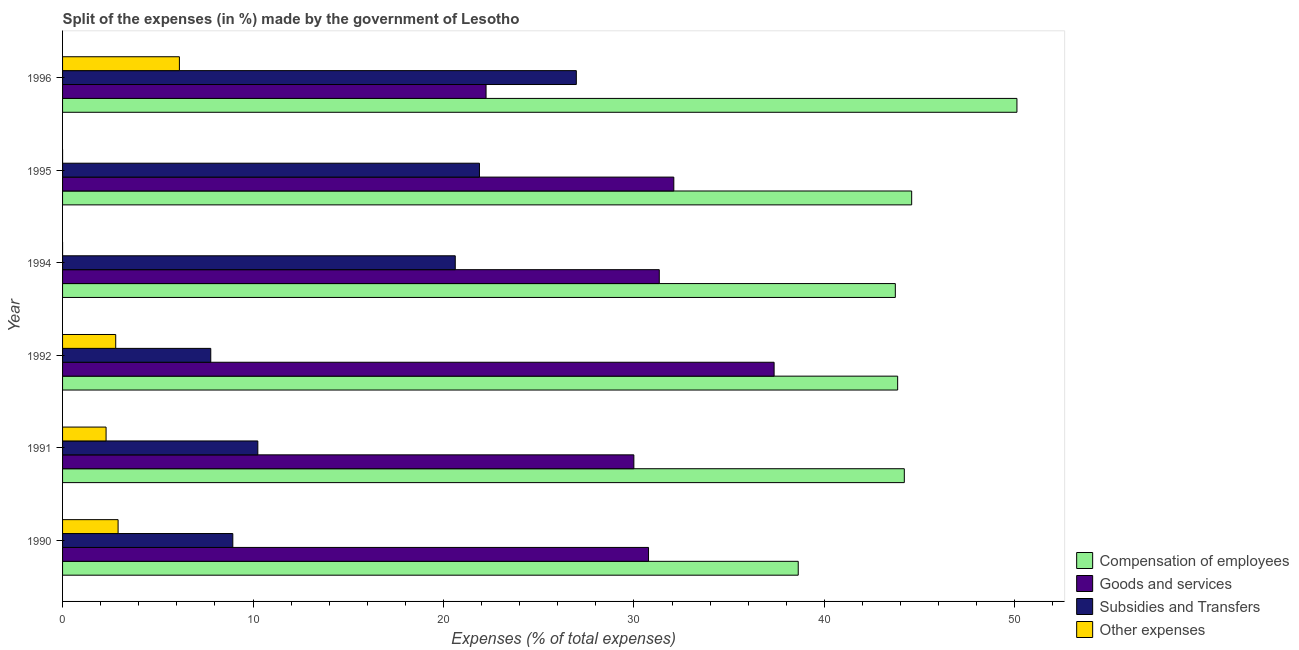How many groups of bars are there?
Ensure brevity in your answer.  6. Are the number of bars per tick equal to the number of legend labels?
Keep it short and to the point. Yes. Are the number of bars on each tick of the Y-axis equal?
Give a very brief answer. Yes. In how many cases, is the number of bars for a given year not equal to the number of legend labels?
Your answer should be compact. 0. What is the percentage of amount spent on goods and services in 1992?
Keep it short and to the point. 37.36. Across all years, what is the maximum percentage of amount spent on goods and services?
Make the answer very short. 37.36. Across all years, what is the minimum percentage of amount spent on subsidies?
Ensure brevity in your answer.  7.78. In which year was the percentage of amount spent on subsidies minimum?
Offer a very short reply. 1992. What is the total percentage of amount spent on other expenses in the graph?
Your response must be concise. 14.13. What is the difference between the percentage of amount spent on compensation of employees in 1992 and that in 1995?
Ensure brevity in your answer.  -0.74. What is the difference between the percentage of amount spent on subsidies in 1995 and the percentage of amount spent on other expenses in 1990?
Offer a terse response. 18.97. What is the average percentage of amount spent on compensation of employees per year?
Ensure brevity in your answer.  44.18. In the year 1992, what is the difference between the percentage of amount spent on goods and services and percentage of amount spent on other expenses?
Keep it short and to the point. 34.57. What is the ratio of the percentage of amount spent on compensation of employees in 1994 to that in 1995?
Make the answer very short. 0.98. Is the percentage of amount spent on subsidies in 1992 less than that in 1996?
Your response must be concise. Yes. Is the difference between the percentage of amount spent on goods and services in 1990 and 1994 greater than the difference between the percentage of amount spent on compensation of employees in 1990 and 1994?
Your response must be concise. Yes. What is the difference between the highest and the second highest percentage of amount spent on goods and services?
Provide a succinct answer. 5.27. What is the difference between the highest and the lowest percentage of amount spent on goods and services?
Your answer should be very brief. 15.12. In how many years, is the percentage of amount spent on compensation of employees greater than the average percentage of amount spent on compensation of employees taken over all years?
Provide a succinct answer. 3. Is the sum of the percentage of amount spent on goods and services in 1990 and 1991 greater than the maximum percentage of amount spent on other expenses across all years?
Your answer should be compact. Yes. Is it the case that in every year, the sum of the percentage of amount spent on subsidies and percentage of amount spent on compensation of employees is greater than the sum of percentage of amount spent on goods and services and percentage of amount spent on other expenses?
Your answer should be very brief. No. What does the 3rd bar from the top in 1995 represents?
Your response must be concise. Goods and services. What does the 3rd bar from the bottom in 1994 represents?
Ensure brevity in your answer.  Subsidies and Transfers. Is it the case that in every year, the sum of the percentage of amount spent on compensation of employees and percentage of amount spent on goods and services is greater than the percentage of amount spent on subsidies?
Provide a succinct answer. Yes. Are the values on the major ticks of X-axis written in scientific E-notation?
Provide a short and direct response. No. Does the graph contain any zero values?
Ensure brevity in your answer.  No. How many legend labels are there?
Make the answer very short. 4. What is the title of the graph?
Your answer should be compact. Split of the expenses (in %) made by the government of Lesotho. What is the label or title of the X-axis?
Offer a very short reply. Expenses (% of total expenses). What is the Expenses (% of total expenses) of Compensation of employees in 1990?
Your answer should be very brief. 38.63. What is the Expenses (% of total expenses) of Goods and services in 1990?
Offer a very short reply. 30.77. What is the Expenses (% of total expenses) of Subsidies and Transfers in 1990?
Make the answer very short. 8.94. What is the Expenses (% of total expenses) of Other expenses in 1990?
Your response must be concise. 2.92. What is the Expenses (% of total expenses) of Compensation of employees in 1991?
Offer a very short reply. 44.2. What is the Expenses (% of total expenses) of Goods and services in 1991?
Provide a succinct answer. 30. What is the Expenses (% of total expenses) of Subsidies and Transfers in 1991?
Your response must be concise. 10.25. What is the Expenses (% of total expenses) of Other expenses in 1991?
Provide a succinct answer. 2.28. What is the Expenses (% of total expenses) in Compensation of employees in 1992?
Give a very brief answer. 43.85. What is the Expenses (% of total expenses) of Goods and services in 1992?
Your response must be concise. 37.36. What is the Expenses (% of total expenses) in Subsidies and Transfers in 1992?
Provide a short and direct response. 7.78. What is the Expenses (% of total expenses) in Other expenses in 1992?
Your answer should be very brief. 2.79. What is the Expenses (% of total expenses) in Compensation of employees in 1994?
Provide a short and direct response. 43.73. What is the Expenses (% of total expenses) in Goods and services in 1994?
Your answer should be very brief. 31.33. What is the Expenses (% of total expenses) of Subsidies and Transfers in 1994?
Your answer should be very brief. 20.62. What is the Expenses (% of total expenses) in Other expenses in 1994?
Make the answer very short. 2.999997087200831e-5. What is the Expenses (% of total expenses) in Compensation of employees in 1995?
Make the answer very short. 44.58. What is the Expenses (% of total expenses) in Goods and services in 1995?
Your answer should be compact. 32.1. What is the Expenses (% of total expenses) in Subsidies and Transfers in 1995?
Your answer should be very brief. 21.89. What is the Expenses (% of total expenses) in Other expenses in 1995?
Make the answer very short. 0. What is the Expenses (% of total expenses) in Compensation of employees in 1996?
Give a very brief answer. 50.11. What is the Expenses (% of total expenses) in Goods and services in 1996?
Give a very brief answer. 22.24. What is the Expenses (% of total expenses) of Subsidies and Transfers in 1996?
Ensure brevity in your answer.  26.98. What is the Expenses (% of total expenses) of Other expenses in 1996?
Offer a very short reply. 6.14. Across all years, what is the maximum Expenses (% of total expenses) of Compensation of employees?
Your answer should be compact. 50.11. Across all years, what is the maximum Expenses (% of total expenses) of Goods and services?
Offer a very short reply. 37.36. Across all years, what is the maximum Expenses (% of total expenses) of Subsidies and Transfers?
Your answer should be very brief. 26.98. Across all years, what is the maximum Expenses (% of total expenses) in Other expenses?
Offer a very short reply. 6.14. Across all years, what is the minimum Expenses (% of total expenses) of Compensation of employees?
Provide a succinct answer. 38.63. Across all years, what is the minimum Expenses (% of total expenses) in Goods and services?
Your answer should be compact. 22.24. Across all years, what is the minimum Expenses (% of total expenses) of Subsidies and Transfers?
Your answer should be compact. 7.78. Across all years, what is the minimum Expenses (% of total expenses) of Other expenses?
Give a very brief answer. 2.999997087200831e-5. What is the total Expenses (% of total expenses) of Compensation of employees in the graph?
Keep it short and to the point. 265.1. What is the total Expenses (% of total expenses) of Goods and services in the graph?
Make the answer very short. 183.79. What is the total Expenses (% of total expenses) of Subsidies and Transfers in the graph?
Keep it short and to the point. 96.46. What is the total Expenses (% of total expenses) in Other expenses in the graph?
Make the answer very short. 14.13. What is the difference between the Expenses (% of total expenses) of Compensation of employees in 1990 and that in 1991?
Offer a terse response. -5.57. What is the difference between the Expenses (% of total expenses) in Goods and services in 1990 and that in 1991?
Your answer should be very brief. 0.77. What is the difference between the Expenses (% of total expenses) in Subsidies and Transfers in 1990 and that in 1991?
Give a very brief answer. -1.31. What is the difference between the Expenses (% of total expenses) of Other expenses in 1990 and that in 1991?
Give a very brief answer. 0.63. What is the difference between the Expenses (% of total expenses) in Compensation of employees in 1990 and that in 1992?
Your answer should be very brief. -5.22. What is the difference between the Expenses (% of total expenses) of Goods and services in 1990 and that in 1992?
Keep it short and to the point. -6.59. What is the difference between the Expenses (% of total expenses) of Subsidies and Transfers in 1990 and that in 1992?
Give a very brief answer. 1.16. What is the difference between the Expenses (% of total expenses) of Other expenses in 1990 and that in 1992?
Your answer should be very brief. 0.13. What is the difference between the Expenses (% of total expenses) of Compensation of employees in 1990 and that in 1994?
Make the answer very short. -5.1. What is the difference between the Expenses (% of total expenses) of Goods and services in 1990 and that in 1994?
Ensure brevity in your answer.  -0.56. What is the difference between the Expenses (% of total expenses) of Subsidies and Transfers in 1990 and that in 1994?
Make the answer very short. -11.68. What is the difference between the Expenses (% of total expenses) in Other expenses in 1990 and that in 1994?
Make the answer very short. 2.92. What is the difference between the Expenses (% of total expenses) in Compensation of employees in 1990 and that in 1995?
Your response must be concise. -5.96. What is the difference between the Expenses (% of total expenses) in Goods and services in 1990 and that in 1995?
Make the answer very short. -1.33. What is the difference between the Expenses (% of total expenses) in Subsidies and Transfers in 1990 and that in 1995?
Offer a very short reply. -12.95. What is the difference between the Expenses (% of total expenses) of Other expenses in 1990 and that in 1995?
Provide a short and direct response. 2.92. What is the difference between the Expenses (% of total expenses) in Compensation of employees in 1990 and that in 1996?
Make the answer very short. -11.48. What is the difference between the Expenses (% of total expenses) in Goods and services in 1990 and that in 1996?
Your answer should be very brief. 8.53. What is the difference between the Expenses (% of total expenses) of Subsidies and Transfers in 1990 and that in 1996?
Offer a terse response. -18.04. What is the difference between the Expenses (% of total expenses) of Other expenses in 1990 and that in 1996?
Your response must be concise. -3.22. What is the difference between the Expenses (% of total expenses) in Compensation of employees in 1991 and that in 1992?
Give a very brief answer. 0.35. What is the difference between the Expenses (% of total expenses) of Goods and services in 1991 and that in 1992?
Make the answer very short. -7.36. What is the difference between the Expenses (% of total expenses) in Subsidies and Transfers in 1991 and that in 1992?
Ensure brevity in your answer.  2.47. What is the difference between the Expenses (% of total expenses) of Other expenses in 1991 and that in 1992?
Offer a terse response. -0.51. What is the difference between the Expenses (% of total expenses) of Compensation of employees in 1991 and that in 1994?
Your answer should be compact. 0.47. What is the difference between the Expenses (% of total expenses) of Goods and services in 1991 and that in 1994?
Provide a short and direct response. -1.33. What is the difference between the Expenses (% of total expenses) in Subsidies and Transfers in 1991 and that in 1994?
Provide a succinct answer. -10.37. What is the difference between the Expenses (% of total expenses) of Other expenses in 1991 and that in 1994?
Offer a very short reply. 2.28. What is the difference between the Expenses (% of total expenses) of Compensation of employees in 1991 and that in 1995?
Offer a terse response. -0.39. What is the difference between the Expenses (% of total expenses) in Goods and services in 1991 and that in 1995?
Make the answer very short. -2.1. What is the difference between the Expenses (% of total expenses) in Subsidies and Transfers in 1991 and that in 1995?
Offer a very short reply. -11.64. What is the difference between the Expenses (% of total expenses) in Other expenses in 1991 and that in 1995?
Provide a short and direct response. 2.28. What is the difference between the Expenses (% of total expenses) in Compensation of employees in 1991 and that in 1996?
Your answer should be very brief. -5.91. What is the difference between the Expenses (% of total expenses) of Goods and services in 1991 and that in 1996?
Provide a succinct answer. 7.76. What is the difference between the Expenses (% of total expenses) of Subsidies and Transfers in 1991 and that in 1996?
Make the answer very short. -16.72. What is the difference between the Expenses (% of total expenses) in Other expenses in 1991 and that in 1996?
Provide a succinct answer. -3.85. What is the difference between the Expenses (% of total expenses) of Compensation of employees in 1992 and that in 1994?
Provide a short and direct response. 0.12. What is the difference between the Expenses (% of total expenses) in Goods and services in 1992 and that in 1994?
Make the answer very short. 6.03. What is the difference between the Expenses (% of total expenses) in Subsidies and Transfers in 1992 and that in 1994?
Offer a very short reply. -12.84. What is the difference between the Expenses (% of total expenses) in Other expenses in 1992 and that in 1994?
Make the answer very short. 2.79. What is the difference between the Expenses (% of total expenses) of Compensation of employees in 1992 and that in 1995?
Make the answer very short. -0.74. What is the difference between the Expenses (% of total expenses) in Goods and services in 1992 and that in 1995?
Keep it short and to the point. 5.27. What is the difference between the Expenses (% of total expenses) in Subsidies and Transfers in 1992 and that in 1995?
Your answer should be compact. -14.11. What is the difference between the Expenses (% of total expenses) in Other expenses in 1992 and that in 1995?
Offer a terse response. 2.79. What is the difference between the Expenses (% of total expenses) of Compensation of employees in 1992 and that in 1996?
Offer a terse response. -6.26. What is the difference between the Expenses (% of total expenses) in Goods and services in 1992 and that in 1996?
Keep it short and to the point. 15.12. What is the difference between the Expenses (% of total expenses) in Subsidies and Transfers in 1992 and that in 1996?
Offer a very short reply. -19.2. What is the difference between the Expenses (% of total expenses) of Other expenses in 1992 and that in 1996?
Your answer should be very brief. -3.34. What is the difference between the Expenses (% of total expenses) in Compensation of employees in 1994 and that in 1995?
Keep it short and to the point. -0.86. What is the difference between the Expenses (% of total expenses) of Goods and services in 1994 and that in 1995?
Offer a very short reply. -0.76. What is the difference between the Expenses (% of total expenses) in Subsidies and Transfers in 1994 and that in 1995?
Offer a very short reply. -1.27. What is the difference between the Expenses (% of total expenses) of Other expenses in 1994 and that in 1995?
Provide a succinct answer. -0. What is the difference between the Expenses (% of total expenses) in Compensation of employees in 1994 and that in 1996?
Your answer should be compact. -6.39. What is the difference between the Expenses (% of total expenses) of Goods and services in 1994 and that in 1996?
Provide a succinct answer. 9.1. What is the difference between the Expenses (% of total expenses) in Subsidies and Transfers in 1994 and that in 1996?
Provide a short and direct response. -6.36. What is the difference between the Expenses (% of total expenses) in Other expenses in 1994 and that in 1996?
Your response must be concise. -6.14. What is the difference between the Expenses (% of total expenses) of Compensation of employees in 1995 and that in 1996?
Offer a terse response. -5.53. What is the difference between the Expenses (% of total expenses) in Goods and services in 1995 and that in 1996?
Offer a terse response. 9.86. What is the difference between the Expenses (% of total expenses) in Subsidies and Transfers in 1995 and that in 1996?
Keep it short and to the point. -5.09. What is the difference between the Expenses (% of total expenses) of Other expenses in 1995 and that in 1996?
Your answer should be very brief. -6.14. What is the difference between the Expenses (% of total expenses) in Compensation of employees in 1990 and the Expenses (% of total expenses) in Goods and services in 1991?
Your answer should be very brief. 8.63. What is the difference between the Expenses (% of total expenses) of Compensation of employees in 1990 and the Expenses (% of total expenses) of Subsidies and Transfers in 1991?
Offer a very short reply. 28.38. What is the difference between the Expenses (% of total expenses) in Compensation of employees in 1990 and the Expenses (% of total expenses) in Other expenses in 1991?
Your answer should be very brief. 36.34. What is the difference between the Expenses (% of total expenses) in Goods and services in 1990 and the Expenses (% of total expenses) in Subsidies and Transfers in 1991?
Ensure brevity in your answer.  20.52. What is the difference between the Expenses (% of total expenses) in Goods and services in 1990 and the Expenses (% of total expenses) in Other expenses in 1991?
Ensure brevity in your answer.  28.48. What is the difference between the Expenses (% of total expenses) of Subsidies and Transfers in 1990 and the Expenses (% of total expenses) of Other expenses in 1991?
Keep it short and to the point. 6.65. What is the difference between the Expenses (% of total expenses) of Compensation of employees in 1990 and the Expenses (% of total expenses) of Goods and services in 1992?
Your response must be concise. 1.27. What is the difference between the Expenses (% of total expenses) of Compensation of employees in 1990 and the Expenses (% of total expenses) of Subsidies and Transfers in 1992?
Make the answer very short. 30.85. What is the difference between the Expenses (% of total expenses) of Compensation of employees in 1990 and the Expenses (% of total expenses) of Other expenses in 1992?
Provide a short and direct response. 35.84. What is the difference between the Expenses (% of total expenses) of Goods and services in 1990 and the Expenses (% of total expenses) of Subsidies and Transfers in 1992?
Provide a succinct answer. 22.99. What is the difference between the Expenses (% of total expenses) in Goods and services in 1990 and the Expenses (% of total expenses) in Other expenses in 1992?
Your response must be concise. 27.98. What is the difference between the Expenses (% of total expenses) in Subsidies and Transfers in 1990 and the Expenses (% of total expenses) in Other expenses in 1992?
Your answer should be very brief. 6.15. What is the difference between the Expenses (% of total expenses) of Compensation of employees in 1990 and the Expenses (% of total expenses) of Goods and services in 1994?
Make the answer very short. 7.3. What is the difference between the Expenses (% of total expenses) of Compensation of employees in 1990 and the Expenses (% of total expenses) of Subsidies and Transfers in 1994?
Ensure brevity in your answer.  18.01. What is the difference between the Expenses (% of total expenses) in Compensation of employees in 1990 and the Expenses (% of total expenses) in Other expenses in 1994?
Give a very brief answer. 38.63. What is the difference between the Expenses (% of total expenses) in Goods and services in 1990 and the Expenses (% of total expenses) in Subsidies and Transfers in 1994?
Give a very brief answer. 10.15. What is the difference between the Expenses (% of total expenses) in Goods and services in 1990 and the Expenses (% of total expenses) in Other expenses in 1994?
Ensure brevity in your answer.  30.77. What is the difference between the Expenses (% of total expenses) in Subsidies and Transfers in 1990 and the Expenses (% of total expenses) in Other expenses in 1994?
Your response must be concise. 8.94. What is the difference between the Expenses (% of total expenses) in Compensation of employees in 1990 and the Expenses (% of total expenses) in Goods and services in 1995?
Your answer should be very brief. 6.53. What is the difference between the Expenses (% of total expenses) of Compensation of employees in 1990 and the Expenses (% of total expenses) of Subsidies and Transfers in 1995?
Offer a terse response. 16.74. What is the difference between the Expenses (% of total expenses) of Compensation of employees in 1990 and the Expenses (% of total expenses) of Other expenses in 1995?
Make the answer very short. 38.63. What is the difference between the Expenses (% of total expenses) in Goods and services in 1990 and the Expenses (% of total expenses) in Subsidies and Transfers in 1995?
Keep it short and to the point. 8.88. What is the difference between the Expenses (% of total expenses) of Goods and services in 1990 and the Expenses (% of total expenses) of Other expenses in 1995?
Offer a very short reply. 30.77. What is the difference between the Expenses (% of total expenses) of Subsidies and Transfers in 1990 and the Expenses (% of total expenses) of Other expenses in 1995?
Ensure brevity in your answer.  8.94. What is the difference between the Expenses (% of total expenses) of Compensation of employees in 1990 and the Expenses (% of total expenses) of Goods and services in 1996?
Make the answer very short. 16.39. What is the difference between the Expenses (% of total expenses) in Compensation of employees in 1990 and the Expenses (% of total expenses) in Subsidies and Transfers in 1996?
Make the answer very short. 11.65. What is the difference between the Expenses (% of total expenses) of Compensation of employees in 1990 and the Expenses (% of total expenses) of Other expenses in 1996?
Ensure brevity in your answer.  32.49. What is the difference between the Expenses (% of total expenses) of Goods and services in 1990 and the Expenses (% of total expenses) of Subsidies and Transfers in 1996?
Provide a short and direct response. 3.79. What is the difference between the Expenses (% of total expenses) of Goods and services in 1990 and the Expenses (% of total expenses) of Other expenses in 1996?
Your answer should be compact. 24.63. What is the difference between the Expenses (% of total expenses) in Subsidies and Transfers in 1990 and the Expenses (% of total expenses) in Other expenses in 1996?
Your response must be concise. 2.8. What is the difference between the Expenses (% of total expenses) of Compensation of employees in 1991 and the Expenses (% of total expenses) of Goods and services in 1992?
Provide a succinct answer. 6.84. What is the difference between the Expenses (% of total expenses) of Compensation of employees in 1991 and the Expenses (% of total expenses) of Subsidies and Transfers in 1992?
Offer a very short reply. 36.42. What is the difference between the Expenses (% of total expenses) in Compensation of employees in 1991 and the Expenses (% of total expenses) in Other expenses in 1992?
Offer a terse response. 41.41. What is the difference between the Expenses (% of total expenses) of Goods and services in 1991 and the Expenses (% of total expenses) of Subsidies and Transfers in 1992?
Offer a very short reply. 22.22. What is the difference between the Expenses (% of total expenses) of Goods and services in 1991 and the Expenses (% of total expenses) of Other expenses in 1992?
Ensure brevity in your answer.  27.21. What is the difference between the Expenses (% of total expenses) in Subsidies and Transfers in 1991 and the Expenses (% of total expenses) in Other expenses in 1992?
Keep it short and to the point. 7.46. What is the difference between the Expenses (% of total expenses) of Compensation of employees in 1991 and the Expenses (% of total expenses) of Goods and services in 1994?
Give a very brief answer. 12.87. What is the difference between the Expenses (% of total expenses) in Compensation of employees in 1991 and the Expenses (% of total expenses) in Subsidies and Transfers in 1994?
Keep it short and to the point. 23.58. What is the difference between the Expenses (% of total expenses) in Compensation of employees in 1991 and the Expenses (% of total expenses) in Other expenses in 1994?
Your answer should be compact. 44.2. What is the difference between the Expenses (% of total expenses) in Goods and services in 1991 and the Expenses (% of total expenses) in Subsidies and Transfers in 1994?
Your response must be concise. 9.38. What is the difference between the Expenses (% of total expenses) in Goods and services in 1991 and the Expenses (% of total expenses) in Other expenses in 1994?
Provide a short and direct response. 30. What is the difference between the Expenses (% of total expenses) in Subsidies and Transfers in 1991 and the Expenses (% of total expenses) in Other expenses in 1994?
Make the answer very short. 10.25. What is the difference between the Expenses (% of total expenses) in Compensation of employees in 1991 and the Expenses (% of total expenses) in Goods and services in 1995?
Your response must be concise. 12.1. What is the difference between the Expenses (% of total expenses) in Compensation of employees in 1991 and the Expenses (% of total expenses) in Subsidies and Transfers in 1995?
Provide a short and direct response. 22.31. What is the difference between the Expenses (% of total expenses) of Compensation of employees in 1991 and the Expenses (% of total expenses) of Other expenses in 1995?
Give a very brief answer. 44.2. What is the difference between the Expenses (% of total expenses) in Goods and services in 1991 and the Expenses (% of total expenses) in Subsidies and Transfers in 1995?
Provide a succinct answer. 8.11. What is the difference between the Expenses (% of total expenses) of Goods and services in 1991 and the Expenses (% of total expenses) of Other expenses in 1995?
Make the answer very short. 30. What is the difference between the Expenses (% of total expenses) in Subsidies and Transfers in 1991 and the Expenses (% of total expenses) in Other expenses in 1995?
Your response must be concise. 10.25. What is the difference between the Expenses (% of total expenses) of Compensation of employees in 1991 and the Expenses (% of total expenses) of Goods and services in 1996?
Your answer should be very brief. 21.96. What is the difference between the Expenses (% of total expenses) in Compensation of employees in 1991 and the Expenses (% of total expenses) in Subsidies and Transfers in 1996?
Ensure brevity in your answer.  17.22. What is the difference between the Expenses (% of total expenses) in Compensation of employees in 1991 and the Expenses (% of total expenses) in Other expenses in 1996?
Provide a succinct answer. 38.06. What is the difference between the Expenses (% of total expenses) of Goods and services in 1991 and the Expenses (% of total expenses) of Subsidies and Transfers in 1996?
Provide a succinct answer. 3.02. What is the difference between the Expenses (% of total expenses) in Goods and services in 1991 and the Expenses (% of total expenses) in Other expenses in 1996?
Keep it short and to the point. 23.86. What is the difference between the Expenses (% of total expenses) of Subsidies and Transfers in 1991 and the Expenses (% of total expenses) of Other expenses in 1996?
Offer a very short reply. 4.12. What is the difference between the Expenses (% of total expenses) in Compensation of employees in 1992 and the Expenses (% of total expenses) in Goods and services in 1994?
Offer a terse response. 12.52. What is the difference between the Expenses (% of total expenses) of Compensation of employees in 1992 and the Expenses (% of total expenses) of Subsidies and Transfers in 1994?
Make the answer very short. 23.23. What is the difference between the Expenses (% of total expenses) of Compensation of employees in 1992 and the Expenses (% of total expenses) of Other expenses in 1994?
Provide a succinct answer. 43.85. What is the difference between the Expenses (% of total expenses) of Goods and services in 1992 and the Expenses (% of total expenses) of Subsidies and Transfers in 1994?
Make the answer very short. 16.74. What is the difference between the Expenses (% of total expenses) of Goods and services in 1992 and the Expenses (% of total expenses) of Other expenses in 1994?
Ensure brevity in your answer.  37.36. What is the difference between the Expenses (% of total expenses) in Subsidies and Transfers in 1992 and the Expenses (% of total expenses) in Other expenses in 1994?
Your answer should be compact. 7.78. What is the difference between the Expenses (% of total expenses) in Compensation of employees in 1992 and the Expenses (% of total expenses) in Goods and services in 1995?
Your response must be concise. 11.75. What is the difference between the Expenses (% of total expenses) in Compensation of employees in 1992 and the Expenses (% of total expenses) in Subsidies and Transfers in 1995?
Ensure brevity in your answer.  21.96. What is the difference between the Expenses (% of total expenses) in Compensation of employees in 1992 and the Expenses (% of total expenses) in Other expenses in 1995?
Give a very brief answer. 43.85. What is the difference between the Expenses (% of total expenses) in Goods and services in 1992 and the Expenses (% of total expenses) in Subsidies and Transfers in 1995?
Your response must be concise. 15.47. What is the difference between the Expenses (% of total expenses) of Goods and services in 1992 and the Expenses (% of total expenses) of Other expenses in 1995?
Your response must be concise. 37.36. What is the difference between the Expenses (% of total expenses) of Subsidies and Transfers in 1992 and the Expenses (% of total expenses) of Other expenses in 1995?
Your response must be concise. 7.78. What is the difference between the Expenses (% of total expenses) of Compensation of employees in 1992 and the Expenses (% of total expenses) of Goods and services in 1996?
Offer a very short reply. 21.61. What is the difference between the Expenses (% of total expenses) in Compensation of employees in 1992 and the Expenses (% of total expenses) in Subsidies and Transfers in 1996?
Provide a succinct answer. 16.87. What is the difference between the Expenses (% of total expenses) in Compensation of employees in 1992 and the Expenses (% of total expenses) in Other expenses in 1996?
Your answer should be very brief. 37.71. What is the difference between the Expenses (% of total expenses) of Goods and services in 1992 and the Expenses (% of total expenses) of Subsidies and Transfers in 1996?
Provide a short and direct response. 10.38. What is the difference between the Expenses (% of total expenses) in Goods and services in 1992 and the Expenses (% of total expenses) in Other expenses in 1996?
Offer a very short reply. 31.23. What is the difference between the Expenses (% of total expenses) of Subsidies and Transfers in 1992 and the Expenses (% of total expenses) of Other expenses in 1996?
Provide a short and direct response. 1.65. What is the difference between the Expenses (% of total expenses) of Compensation of employees in 1994 and the Expenses (% of total expenses) of Goods and services in 1995?
Offer a very short reply. 11.63. What is the difference between the Expenses (% of total expenses) in Compensation of employees in 1994 and the Expenses (% of total expenses) in Subsidies and Transfers in 1995?
Give a very brief answer. 21.84. What is the difference between the Expenses (% of total expenses) in Compensation of employees in 1994 and the Expenses (% of total expenses) in Other expenses in 1995?
Offer a terse response. 43.73. What is the difference between the Expenses (% of total expenses) in Goods and services in 1994 and the Expenses (% of total expenses) in Subsidies and Transfers in 1995?
Your answer should be very brief. 9.44. What is the difference between the Expenses (% of total expenses) of Goods and services in 1994 and the Expenses (% of total expenses) of Other expenses in 1995?
Provide a short and direct response. 31.33. What is the difference between the Expenses (% of total expenses) in Subsidies and Transfers in 1994 and the Expenses (% of total expenses) in Other expenses in 1995?
Ensure brevity in your answer.  20.62. What is the difference between the Expenses (% of total expenses) of Compensation of employees in 1994 and the Expenses (% of total expenses) of Goods and services in 1996?
Give a very brief answer. 21.49. What is the difference between the Expenses (% of total expenses) of Compensation of employees in 1994 and the Expenses (% of total expenses) of Subsidies and Transfers in 1996?
Offer a very short reply. 16.75. What is the difference between the Expenses (% of total expenses) of Compensation of employees in 1994 and the Expenses (% of total expenses) of Other expenses in 1996?
Keep it short and to the point. 37.59. What is the difference between the Expenses (% of total expenses) of Goods and services in 1994 and the Expenses (% of total expenses) of Subsidies and Transfers in 1996?
Ensure brevity in your answer.  4.36. What is the difference between the Expenses (% of total expenses) in Goods and services in 1994 and the Expenses (% of total expenses) in Other expenses in 1996?
Offer a terse response. 25.2. What is the difference between the Expenses (% of total expenses) of Subsidies and Transfers in 1994 and the Expenses (% of total expenses) of Other expenses in 1996?
Offer a very short reply. 14.48. What is the difference between the Expenses (% of total expenses) in Compensation of employees in 1995 and the Expenses (% of total expenses) in Goods and services in 1996?
Ensure brevity in your answer.  22.35. What is the difference between the Expenses (% of total expenses) in Compensation of employees in 1995 and the Expenses (% of total expenses) in Subsidies and Transfers in 1996?
Your answer should be compact. 17.61. What is the difference between the Expenses (% of total expenses) in Compensation of employees in 1995 and the Expenses (% of total expenses) in Other expenses in 1996?
Provide a succinct answer. 38.45. What is the difference between the Expenses (% of total expenses) of Goods and services in 1995 and the Expenses (% of total expenses) of Subsidies and Transfers in 1996?
Provide a short and direct response. 5.12. What is the difference between the Expenses (% of total expenses) of Goods and services in 1995 and the Expenses (% of total expenses) of Other expenses in 1996?
Your answer should be very brief. 25.96. What is the difference between the Expenses (% of total expenses) of Subsidies and Transfers in 1995 and the Expenses (% of total expenses) of Other expenses in 1996?
Keep it short and to the point. 15.75. What is the average Expenses (% of total expenses) in Compensation of employees per year?
Ensure brevity in your answer.  44.18. What is the average Expenses (% of total expenses) of Goods and services per year?
Your answer should be compact. 30.63. What is the average Expenses (% of total expenses) in Subsidies and Transfers per year?
Keep it short and to the point. 16.08. What is the average Expenses (% of total expenses) of Other expenses per year?
Provide a succinct answer. 2.35. In the year 1990, what is the difference between the Expenses (% of total expenses) of Compensation of employees and Expenses (% of total expenses) of Goods and services?
Your answer should be compact. 7.86. In the year 1990, what is the difference between the Expenses (% of total expenses) of Compensation of employees and Expenses (% of total expenses) of Subsidies and Transfers?
Keep it short and to the point. 29.69. In the year 1990, what is the difference between the Expenses (% of total expenses) in Compensation of employees and Expenses (% of total expenses) in Other expenses?
Your answer should be compact. 35.71. In the year 1990, what is the difference between the Expenses (% of total expenses) in Goods and services and Expenses (% of total expenses) in Subsidies and Transfers?
Offer a very short reply. 21.83. In the year 1990, what is the difference between the Expenses (% of total expenses) of Goods and services and Expenses (% of total expenses) of Other expenses?
Offer a very short reply. 27.85. In the year 1990, what is the difference between the Expenses (% of total expenses) of Subsidies and Transfers and Expenses (% of total expenses) of Other expenses?
Offer a terse response. 6.02. In the year 1991, what is the difference between the Expenses (% of total expenses) in Compensation of employees and Expenses (% of total expenses) in Goods and services?
Provide a short and direct response. 14.2. In the year 1991, what is the difference between the Expenses (% of total expenses) of Compensation of employees and Expenses (% of total expenses) of Subsidies and Transfers?
Ensure brevity in your answer.  33.95. In the year 1991, what is the difference between the Expenses (% of total expenses) in Compensation of employees and Expenses (% of total expenses) in Other expenses?
Offer a very short reply. 41.91. In the year 1991, what is the difference between the Expenses (% of total expenses) of Goods and services and Expenses (% of total expenses) of Subsidies and Transfers?
Ensure brevity in your answer.  19.74. In the year 1991, what is the difference between the Expenses (% of total expenses) in Goods and services and Expenses (% of total expenses) in Other expenses?
Provide a succinct answer. 27.71. In the year 1991, what is the difference between the Expenses (% of total expenses) of Subsidies and Transfers and Expenses (% of total expenses) of Other expenses?
Keep it short and to the point. 7.97. In the year 1992, what is the difference between the Expenses (% of total expenses) of Compensation of employees and Expenses (% of total expenses) of Goods and services?
Offer a very short reply. 6.49. In the year 1992, what is the difference between the Expenses (% of total expenses) in Compensation of employees and Expenses (% of total expenses) in Subsidies and Transfers?
Ensure brevity in your answer.  36.07. In the year 1992, what is the difference between the Expenses (% of total expenses) of Compensation of employees and Expenses (% of total expenses) of Other expenses?
Make the answer very short. 41.06. In the year 1992, what is the difference between the Expenses (% of total expenses) of Goods and services and Expenses (% of total expenses) of Subsidies and Transfers?
Your response must be concise. 29.58. In the year 1992, what is the difference between the Expenses (% of total expenses) of Goods and services and Expenses (% of total expenses) of Other expenses?
Keep it short and to the point. 34.57. In the year 1992, what is the difference between the Expenses (% of total expenses) of Subsidies and Transfers and Expenses (% of total expenses) of Other expenses?
Keep it short and to the point. 4.99. In the year 1994, what is the difference between the Expenses (% of total expenses) in Compensation of employees and Expenses (% of total expenses) in Goods and services?
Your answer should be compact. 12.39. In the year 1994, what is the difference between the Expenses (% of total expenses) in Compensation of employees and Expenses (% of total expenses) in Subsidies and Transfers?
Provide a succinct answer. 23.11. In the year 1994, what is the difference between the Expenses (% of total expenses) of Compensation of employees and Expenses (% of total expenses) of Other expenses?
Your answer should be very brief. 43.73. In the year 1994, what is the difference between the Expenses (% of total expenses) in Goods and services and Expenses (% of total expenses) in Subsidies and Transfers?
Ensure brevity in your answer.  10.71. In the year 1994, what is the difference between the Expenses (% of total expenses) of Goods and services and Expenses (% of total expenses) of Other expenses?
Make the answer very short. 31.33. In the year 1994, what is the difference between the Expenses (% of total expenses) of Subsidies and Transfers and Expenses (% of total expenses) of Other expenses?
Make the answer very short. 20.62. In the year 1995, what is the difference between the Expenses (% of total expenses) in Compensation of employees and Expenses (% of total expenses) in Goods and services?
Give a very brief answer. 12.49. In the year 1995, what is the difference between the Expenses (% of total expenses) in Compensation of employees and Expenses (% of total expenses) in Subsidies and Transfers?
Your answer should be very brief. 22.7. In the year 1995, what is the difference between the Expenses (% of total expenses) in Compensation of employees and Expenses (% of total expenses) in Other expenses?
Give a very brief answer. 44.58. In the year 1995, what is the difference between the Expenses (% of total expenses) in Goods and services and Expenses (% of total expenses) in Subsidies and Transfers?
Provide a short and direct response. 10.21. In the year 1995, what is the difference between the Expenses (% of total expenses) in Goods and services and Expenses (% of total expenses) in Other expenses?
Provide a succinct answer. 32.1. In the year 1995, what is the difference between the Expenses (% of total expenses) of Subsidies and Transfers and Expenses (% of total expenses) of Other expenses?
Your answer should be compact. 21.89. In the year 1996, what is the difference between the Expenses (% of total expenses) of Compensation of employees and Expenses (% of total expenses) of Goods and services?
Give a very brief answer. 27.88. In the year 1996, what is the difference between the Expenses (% of total expenses) of Compensation of employees and Expenses (% of total expenses) of Subsidies and Transfers?
Your response must be concise. 23.14. In the year 1996, what is the difference between the Expenses (% of total expenses) in Compensation of employees and Expenses (% of total expenses) in Other expenses?
Give a very brief answer. 43.98. In the year 1996, what is the difference between the Expenses (% of total expenses) in Goods and services and Expenses (% of total expenses) in Subsidies and Transfers?
Provide a succinct answer. -4.74. In the year 1996, what is the difference between the Expenses (% of total expenses) in Goods and services and Expenses (% of total expenses) in Other expenses?
Provide a succinct answer. 16.1. In the year 1996, what is the difference between the Expenses (% of total expenses) in Subsidies and Transfers and Expenses (% of total expenses) in Other expenses?
Provide a succinct answer. 20.84. What is the ratio of the Expenses (% of total expenses) in Compensation of employees in 1990 to that in 1991?
Make the answer very short. 0.87. What is the ratio of the Expenses (% of total expenses) of Goods and services in 1990 to that in 1991?
Offer a very short reply. 1.03. What is the ratio of the Expenses (% of total expenses) of Subsidies and Transfers in 1990 to that in 1991?
Your response must be concise. 0.87. What is the ratio of the Expenses (% of total expenses) in Other expenses in 1990 to that in 1991?
Your answer should be very brief. 1.28. What is the ratio of the Expenses (% of total expenses) in Compensation of employees in 1990 to that in 1992?
Make the answer very short. 0.88. What is the ratio of the Expenses (% of total expenses) in Goods and services in 1990 to that in 1992?
Offer a very short reply. 0.82. What is the ratio of the Expenses (% of total expenses) in Subsidies and Transfers in 1990 to that in 1992?
Give a very brief answer. 1.15. What is the ratio of the Expenses (% of total expenses) in Other expenses in 1990 to that in 1992?
Provide a succinct answer. 1.04. What is the ratio of the Expenses (% of total expenses) of Compensation of employees in 1990 to that in 1994?
Provide a short and direct response. 0.88. What is the ratio of the Expenses (% of total expenses) in Goods and services in 1990 to that in 1994?
Give a very brief answer. 0.98. What is the ratio of the Expenses (% of total expenses) of Subsidies and Transfers in 1990 to that in 1994?
Keep it short and to the point. 0.43. What is the ratio of the Expenses (% of total expenses) of Other expenses in 1990 to that in 1994?
Your answer should be compact. 9.72e+04. What is the ratio of the Expenses (% of total expenses) in Compensation of employees in 1990 to that in 1995?
Your response must be concise. 0.87. What is the ratio of the Expenses (% of total expenses) in Goods and services in 1990 to that in 1995?
Keep it short and to the point. 0.96. What is the ratio of the Expenses (% of total expenses) in Subsidies and Transfers in 1990 to that in 1995?
Your answer should be very brief. 0.41. What is the ratio of the Expenses (% of total expenses) of Other expenses in 1990 to that in 1995?
Give a very brief answer. 2.91e+04. What is the ratio of the Expenses (% of total expenses) of Compensation of employees in 1990 to that in 1996?
Provide a short and direct response. 0.77. What is the ratio of the Expenses (% of total expenses) of Goods and services in 1990 to that in 1996?
Your answer should be compact. 1.38. What is the ratio of the Expenses (% of total expenses) of Subsidies and Transfers in 1990 to that in 1996?
Offer a terse response. 0.33. What is the ratio of the Expenses (% of total expenses) in Other expenses in 1990 to that in 1996?
Provide a short and direct response. 0.48. What is the ratio of the Expenses (% of total expenses) of Compensation of employees in 1991 to that in 1992?
Ensure brevity in your answer.  1.01. What is the ratio of the Expenses (% of total expenses) in Goods and services in 1991 to that in 1992?
Offer a very short reply. 0.8. What is the ratio of the Expenses (% of total expenses) of Subsidies and Transfers in 1991 to that in 1992?
Keep it short and to the point. 1.32. What is the ratio of the Expenses (% of total expenses) in Other expenses in 1991 to that in 1992?
Give a very brief answer. 0.82. What is the ratio of the Expenses (% of total expenses) of Compensation of employees in 1991 to that in 1994?
Provide a succinct answer. 1.01. What is the ratio of the Expenses (% of total expenses) in Goods and services in 1991 to that in 1994?
Provide a short and direct response. 0.96. What is the ratio of the Expenses (% of total expenses) of Subsidies and Transfers in 1991 to that in 1994?
Your answer should be compact. 0.5. What is the ratio of the Expenses (% of total expenses) in Other expenses in 1991 to that in 1994?
Provide a succinct answer. 7.62e+04. What is the ratio of the Expenses (% of total expenses) of Goods and services in 1991 to that in 1995?
Offer a terse response. 0.93. What is the ratio of the Expenses (% of total expenses) in Subsidies and Transfers in 1991 to that in 1995?
Offer a terse response. 0.47. What is the ratio of the Expenses (% of total expenses) in Other expenses in 1991 to that in 1995?
Your answer should be compact. 2.28e+04. What is the ratio of the Expenses (% of total expenses) in Compensation of employees in 1991 to that in 1996?
Provide a succinct answer. 0.88. What is the ratio of the Expenses (% of total expenses) of Goods and services in 1991 to that in 1996?
Ensure brevity in your answer.  1.35. What is the ratio of the Expenses (% of total expenses) of Subsidies and Transfers in 1991 to that in 1996?
Provide a short and direct response. 0.38. What is the ratio of the Expenses (% of total expenses) in Other expenses in 1991 to that in 1996?
Provide a succinct answer. 0.37. What is the ratio of the Expenses (% of total expenses) of Compensation of employees in 1992 to that in 1994?
Ensure brevity in your answer.  1. What is the ratio of the Expenses (% of total expenses) in Goods and services in 1992 to that in 1994?
Ensure brevity in your answer.  1.19. What is the ratio of the Expenses (% of total expenses) of Subsidies and Transfers in 1992 to that in 1994?
Provide a succinct answer. 0.38. What is the ratio of the Expenses (% of total expenses) in Other expenses in 1992 to that in 1994?
Offer a very short reply. 9.30e+04. What is the ratio of the Expenses (% of total expenses) in Compensation of employees in 1992 to that in 1995?
Your answer should be compact. 0.98. What is the ratio of the Expenses (% of total expenses) of Goods and services in 1992 to that in 1995?
Your answer should be compact. 1.16. What is the ratio of the Expenses (% of total expenses) in Subsidies and Transfers in 1992 to that in 1995?
Keep it short and to the point. 0.36. What is the ratio of the Expenses (% of total expenses) in Other expenses in 1992 to that in 1995?
Your answer should be compact. 2.78e+04. What is the ratio of the Expenses (% of total expenses) of Compensation of employees in 1992 to that in 1996?
Your response must be concise. 0.88. What is the ratio of the Expenses (% of total expenses) in Goods and services in 1992 to that in 1996?
Offer a terse response. 1.68. What is the ratio of the Expenses (% of total expenses) of Subsidies and Transfers in 1992 to that in 1996?
Provide a short and direct response. 0.29. What is the ratio of the Expenses (% of total expenses) of Other expenses in 1992 to that in 1996?
Your answer should be very brief. 0.45. What is the ratio of the Expenses (% of total expenses) of Compensation of employees in 1994 to that in 1995?
Your response must be concise. 0.98. What is the ratio of the Expenses (% of total expenses) in Goods and services in 1994 to that in 1995?
Your answer should be very brief. 0.98. What is the ratio of the Expenses (% of total expenses) of Subsidies and Transfers in 1994 to that in 1995?
Keep it short and to the point. 0.94. What is the ratio of the Expenses (% of total expenses) of Other expenses in 1994 to that in 1995?
Provide a succinct answer. 0.3. What is the ratio of the Expenses (% of total expenses) in Compensation of employees in 1994 to that in 1996?
Make the answer very short. 0.87. What is the ratio of the Expenses (% of total expenses) in Goods and services in 1994 to that in 1996?
Your answer should be compact. 1.41. What is the ratio of the Expenses (% of total expenses) in Subsidies and Transfers in 1994 to that in 1996?
Give a very brief answer. 0.76. What is the ratio of the Expenses (% of total expenses) in Compensation of employees in 1995 to that in 1996?
Keep it short and to the point. 0.89. What is the ratio of the Expenses (% of total expenses) in Goods and services in 1995 to that in 1996?
Your answer should be compact. 1.44. What is the ratio of the Expenses (% of total expenses) of Subsidies and Transfers in 1995 to that in 1996?
Keep it short and to the point. 0.81. What is the difference between the highest and the second highest Expenses (% of total expenses) in Compensation of employees?
Your answer should be very brief. 5.53. What is the difference between the highest and the second highest Expenses (% of total expenses) in Goods and services?
Make the answer very short. 5.27. What is the difference between the highest and the second highest Expenses (% of total expenses) in Subsidies and Transfers?
Make the answer very short. 5.09. What is the difference between the highest and the second highest Expenses (% of total expenses) of Other expenses?
Provide a short and direct response. 3.22. What is the difference between the highest and the lowest Expenses (% of total expenses) in Compensation of employees?
Ensure brevity in your answer.  11.48. What is the difference between the highest and the lowest Expenses (% of total expenses) of Goods and services?
Your answer should be compact. 15.12. What is the difference between the highest and the lowest Expenses (% of total expenses) in Subsidies and Transfers?
Ensure brevity in your answer.  19.2. What is the difference between the highest and the lowest Expenses (% of total expenses) of Other expenses?
Your answer should be compact. 6.14. 